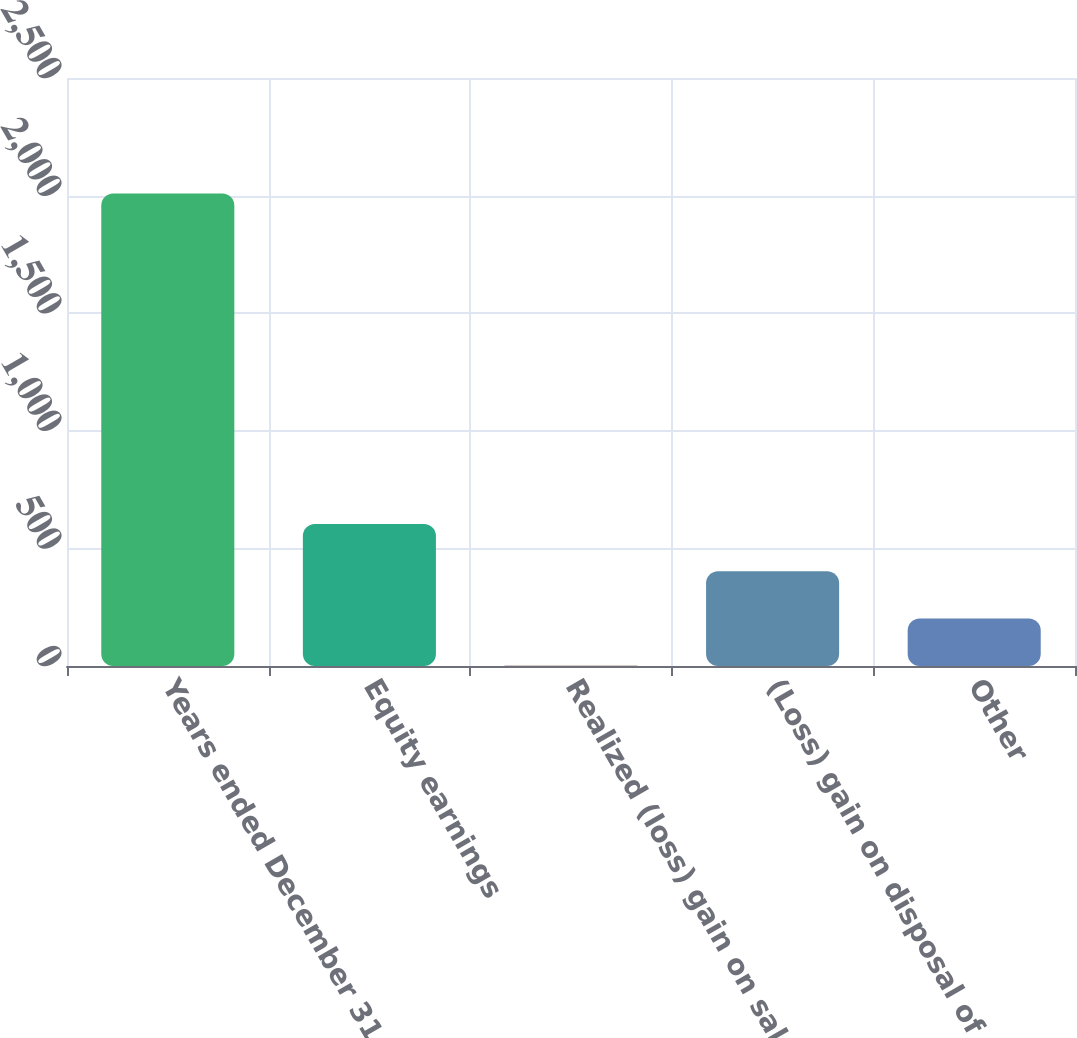<chart> <loc_0><loc_0><loc_500><loc_500><bar_chart><fcel>Years ended December 31<fcel>Equity earnings<fcel>Realized (loss) gain on sale<fcel>(Loss) gain on disposal of<fcel>Other<nl><fcel>2009<fcel>603.4<fcel>1<fcel>402.6<fcel>201.8<nl></chart> 